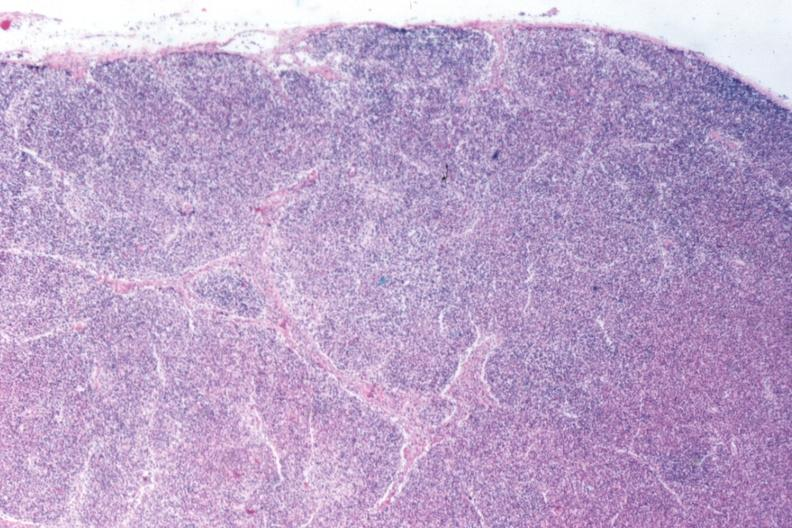does total effacement case appear to have changed into a blast crisis?
Answer the question using a single word or phrase. Yes 